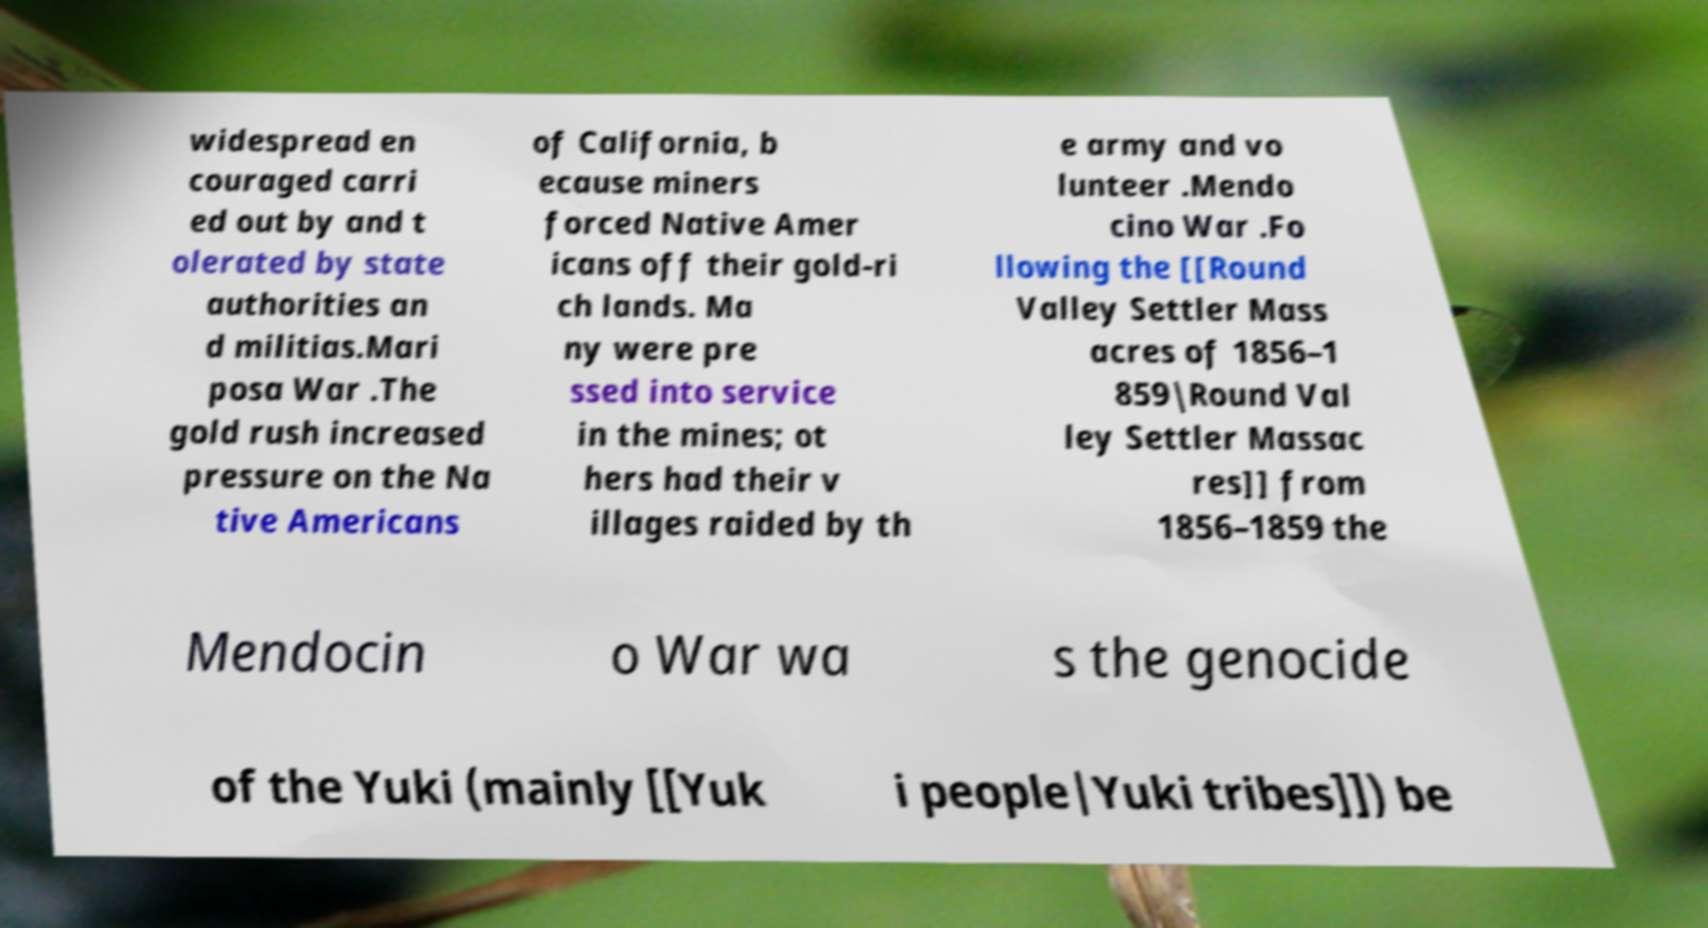Could you extract and type out the text from this image? widespread en couraged carri ed out by and t olerated by state authorities an d militias.Mari posa War .The gold rush increased pressure on the Na tive Americans of California, b ecause miners forced Native Amer icans off their gold-ri ch lands. Ma ny were pre ssed into service in the mines; ot hers had their v illages raided by th e army and vo lunteer .Mendo cino War .Fo llowing the [[Round Valley Settler Mass acres of 1856–1 859|Round Val ley Settler Massac res]] from 1856–1859 the Mendocin o War wa s the genocide of the Yuki (mainly [[Yuk i people|Yuki tribes]]) be 